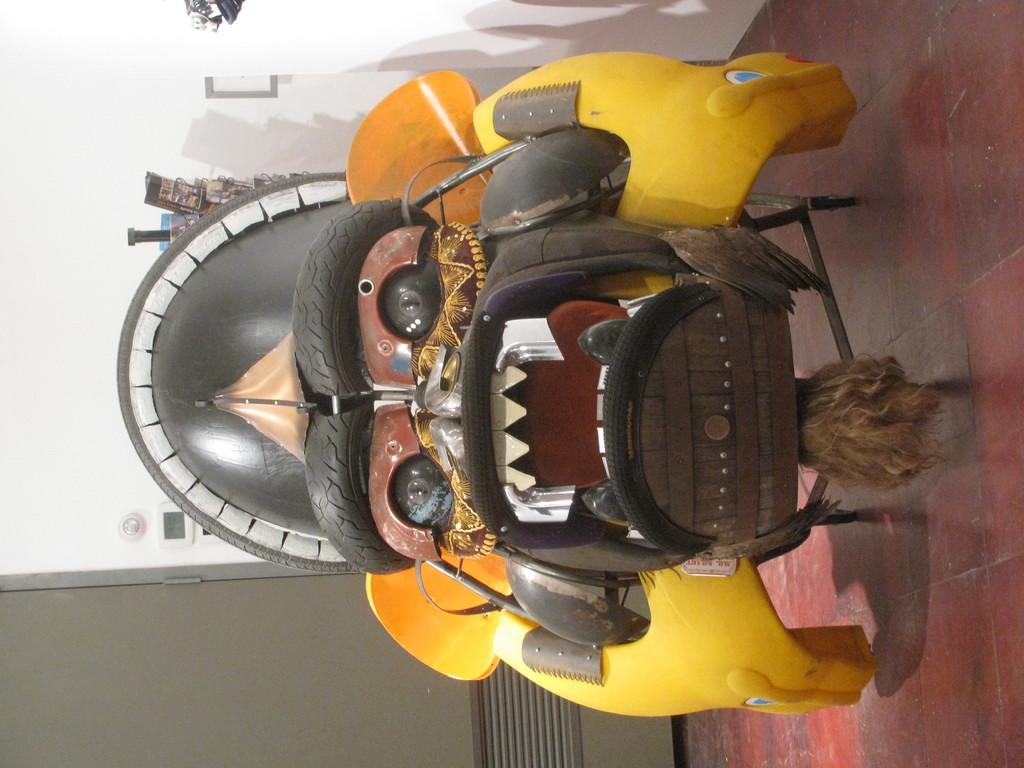What type of toy car is in the image? There is a yellow and brown color decorative dragon toy car in the image. Where is the toy car located? The toy car is placed on the flooring. What can be seen in the background of the image? There is a white wall visible in the background of the image. What type of faucet is present in the image? There is no faucet present in the image; it features a yellow and brown color decorative dragon toy car on the flooring with a white wall in the background. 